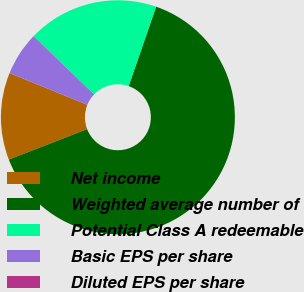Convert chart to OTSL. <chart><loc_0><loc_0><loc_500><loc_500><pie_chart><fcel>Net income<fcel>Weighted average number of<fcel>Potential Class A redeemable<fcel>Basic EPS per share<fcel>Diluted EPS per share<nl><fcel>12.06%<fcel>63.81%<fcel>18.1%<fcel>6.03%<fcel>0.0%<nl></chart> 